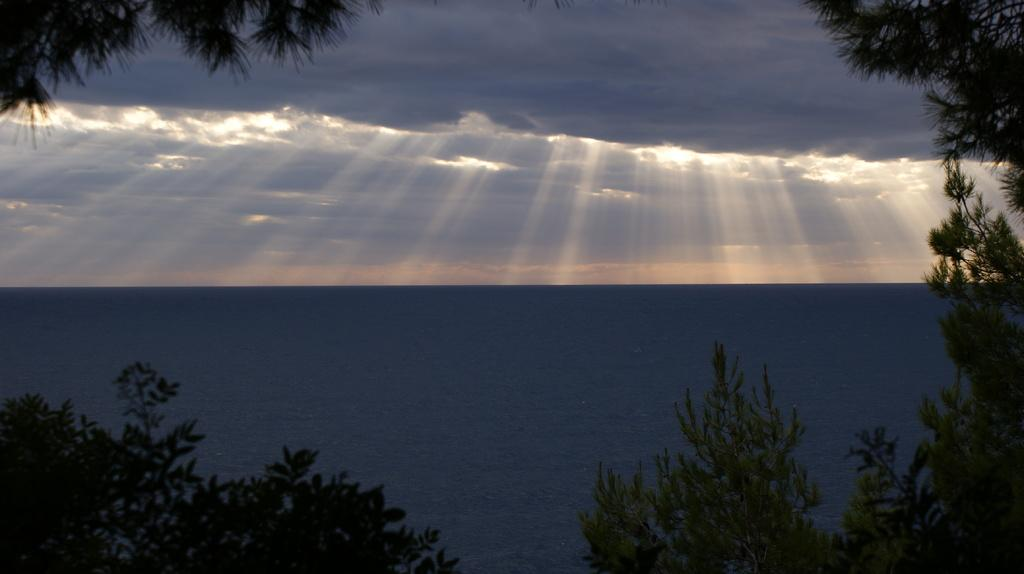What type of vegetation can be seen in the image? There are trees in the image. What natural element is visible in the image besides the trees? There is water visible in the image. How would you describe the sky in the image? The sky is cloudy in the image. What effect can be observed on the water in the image? Rays of light are falling on the water in the image. What type of humor can be seen in the image? There is no humor present in the image; it features trees, water, a cloudy sky, and rays of light falling on the water. How many steps are visible in the image? There are no steps visible in the image. 